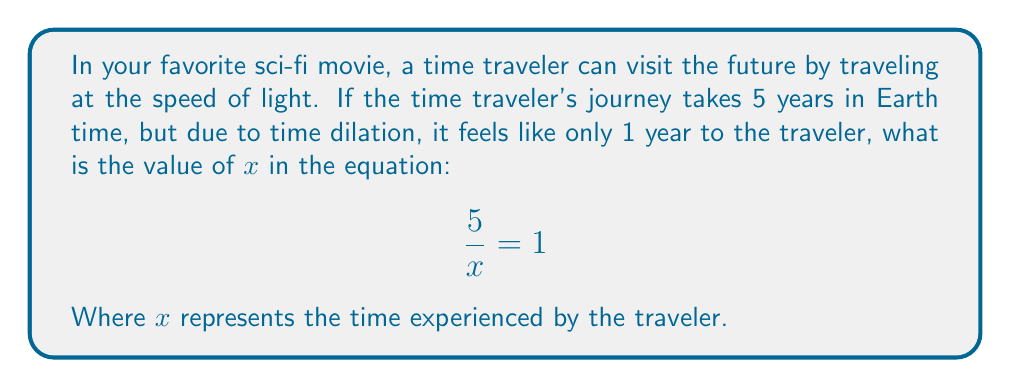Can you solve this math problem? Let's approach this step-by-step:

1) The equation given is $\frac{5}{x} = 1$, where $x$ represents the time experienced by the traveler.

2) To solve for $x$, we need to isolate it on one side of the equation.

3) We can do this by multiplying both sides of the equation by $x$:

   $$x \cdot \frac{5}{x} = x \cdot 1$$

4) The $x$ on the left side cancels out:

   $$5 = x$$

5) Therefore, $x = 5$

6) We can check our answer by substituting it back into the original equation:

   $$\frac{5}{5} = 1$$

   $$1 = 1$$

This confirms our solution is correct.

In the context of the time travel scenario, this means that while 5 years passed on Earth, the traveler experienced 5 years as well, which matches the information given in the question (1 year for the traveler).
Answer: $x = 5$ 